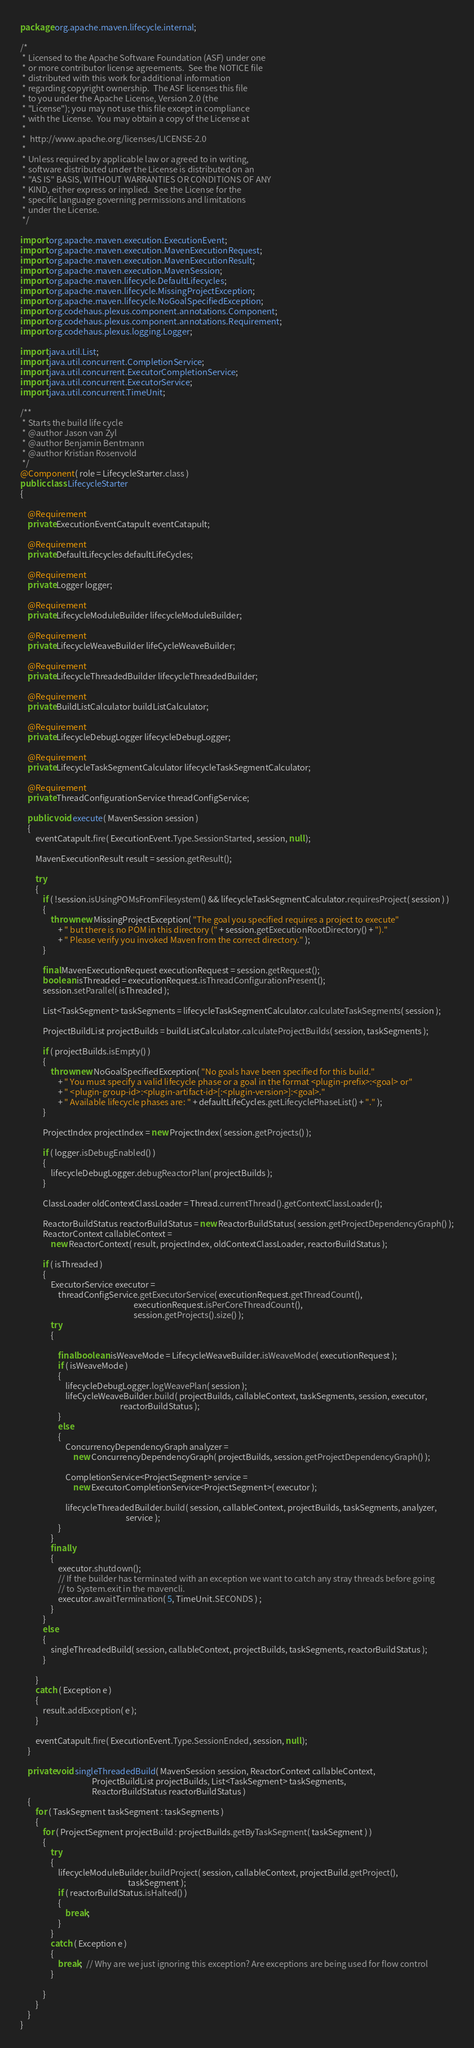Convert code to text. <code><loc_0><loc_0><loc_500><loc_500><_Java_>package org.apache.maven.lifecycle.internal;

/*
 * Licensed to the Apache Software Foundation (ASF) under one
 * or more contributor license agreements.  See the NOTICE file
 * distributed with this work for additional information
 * regarding copyright ownership.  The ASF licenses this file
 * to you under the Apache License, Version 2.0 (the
 * "License"); you may not use this file except in compliance
 * with the License.  You may obtain a copy of the License at
 *
 *  http://www.apache.org/licenses/LICENSE-2.0
 *
 * Unless required by applicable law or agreed to in writing,
 * software distributed under the License is distributed on an
 * "AS IS" BASIS, WITHOUT WARRANTIES OR CONDITIONS OF ANY
 * KIND, either express or implied.  See the License for the
 * specific language governing permissions and limitations
 * under the License.
 */

import org.apache.maven.execution.ExecutionEvent;
import org.apache.maven.execution.MavenExecutionRequest;
import org.apache.maven.execution.MavenExecutionResult;
import org.apache.maven.execution.MavenSession;
import org.apache.maven.lifecycle.DefaultLifecycles;
import org.apache.maven.lifecycle.MissingProjectException;
import org.apache.maven.lifecycle.NoGoalSpecifiedException;
import org.codehaus.plexus.component.annotations.Component;
import org.codehaus.plexus.component.annotations.Requirement;
import org.codehaus.plexus.logging.Logger;

import java.util.List;
import java.util.concurrent.CompletionService;
import java.util.concurrent.ExecutorCompletionService;
import java.util.concurrent.ExecutorService;
import java.util.concurrent.TimeUnit;

/**
 * Starts the build life cycle
 * @author Jason van Zyl
 * @author Benjamin Bentmann
 * @author Kristian Rosenvold
 */
@Component( role = LifecycleStarter.class )
public class LifecycleStarter
{

    @Requirement
    private ExecutionEventCatapult eventCatapult;

    @Requirement
    private DefaultLifecycles defaultLifeCycles;

    @Requirement
    private Logger logger;

    @Requirement
    private LifecycleModuleBuilder lifecycleModuleBuilder;

    @Requirement
    private LifecycleWeaveBuilder lifeCycleWeaveBuilder;

    @Requirement
    private LifecycleThreadedBuilder lifecycleThreadedBuilder;

    @Requirement
    private BuildListCalculator buildListCalculator;

    @Requirement
    private LifecycleDebugLogger lifecycleDebugLogger;

    @Requirement
    private LifecycleTaskSegmentCalculator lifecycleTaskSegmentCalculator;

    @Requirement
    private ThreadConfigurationService threadConfigService;

    public void execute( MavenSession session )
    {
        eventCatapult.fire( ExecutionEvent.Type.SessionStarted, session, null );

        MavenExecutionResult result = session.getResult();

        try
        {
            if ( !session.isUsingPOMsFromFilesystem() && lifecycleTaskSegmentCalculator.requiresProject( session ) )
            {
                throw new MissingProjectException( "The goal you specified requires a project to execute"
                    + " but there is no POM in this directory (" + session.getExecutionRootDirectory() + ")."
                    + " Please verify you invoked Maven from the correct directory." );
            }

            final MavenExecutionRequest executionRequest = session.getRequest();
            boolean isThreaded = executionRequest.isThreadConfigurationPresent();
            session.setParallel( isThreaded );

            List<TaskSegment> taskSegments = lifecycleTaskSegmentCalculator.calculateTaskSegments( session );

            ProjectBuildList projectBuilds = buildListCalculator.calculateProjectBuilds( session, taskSegments );

            if ( projectBuilds.isEmpty() )
            {
                throw new NoGoalSpecifiedException( "No goals have been specified for this build."
                    + " You must specify a valid lifecycle phase or a goal in the format <plugin-prefix>:<goal> or"
                    + " <plugin-group-id>:<plugin-artifact-id>[:<plugin-version>]:<goal>."
                    + " Available lifecycle phases are: " + defaultLifeCycles.getLifecyclePhaseList() + "." );
            }

            ProjectIndex projectIndex = new ProjectIndex( session.getProjects() );

            if ( logger.isDebugEnabled() )
            {
                lifecycleDebugLogger.debugReactorPlan( projectBuilds );
            }

            ClassLoader oldContextClassLoader = Thread.currentThread().getContextClassLoader();

            ReactorBuildStatus reactorBuildStatus = new ReactorBuildStatus( session.getProjectDependencyGraph() );
            ReactorContext callableContext =
                new ReactorContext( result, projectIndex, oldContextClassLoader, reactorBuildStatus );

            if ( isThreaded )
            {
                ExecutorService executor =
                    threadConfigService.getExecutorService( executionRequest.getThreadCount(),
                                                            executionRequest.isPerCoreThreadCount(),
                                                            session.getProjects().size() );
                try
                {

                    final boolean isWeaveMode = LifecycleWeaveBuilder.isWeaveMode( executionRequest );
                    if ( isWeaveMode )
                    {
                        lifecycleDebugLogger.logWeavePlan( session );
                        lifeCycleWeaveBuilder.build( projectBuilds, callableContext, taskSegments, session, executor,
                                                     reactorBuildStatus );
                    }
                    else
                    {
                        ConcurrencyDependencyGraph analyzer =
                            new ConcurrencyDependencyGraph( projectBuilds, session.getProjectDependencyGraph() );

                        CompletionService<ProjectSegment> service =
                            new ExecutorCompletionService<ProjectSegment>( executor );

                        lifecycleThreadedBuilder.build( session, callableContext, projectBuilds, taskSegments, analyzer,
                                                        service );
                    }
                }
                finally
                {
                    executor.shutdown();
                    // If the builder has terminated with an exception we want to catch any stray threads before going
                    // to System.exit in the mavencli.
                    executor.awaitTermination( 5, TimeUnit.SECONDS ) ;
                }
            }
            else
            {
                singleThreadedBuild( session, callableContext, projectBuilds, taskSegments, reactorBuildStatus );
            }

        }
        catch ( Exception e )
        {
            result.addException( e );
        }

        eventCatapult.fire( ExecutionEvent.Type.SessionEnded, session, null );
    }

    private void singleThreadedBuild( MavenSession session, ReactorContext callableContext,
                                      ProjectBuildList projectBuilds, List<TaskSegment> taskSegments,
                                      ReactorBuildStatus reactorBuildStatus )
    {
        for ( TaskSegment taskSegment : taskSegments )
        {
            for ( ProjectSegment projectBuild : projectBuilds.getByTaskSegment( taskSegment ) )
            {
                try
                {
                    lifecycleModuleBuilder.buildProject( session, callableContext, projectBuild.getProject(),
                                                         taskSegment );
                    if ( reactorBuildStatus.isHalted() )
                    {
                        break;
                    }
                }
                catch ( Exception e )
                {
                    break;  // Why are we just ignoring this exception? Are exceptions are being used for flow control
                }

            }
        }
    }
}
</code> 